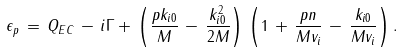Convert formula to latex. <formula><loc_0><loc_0><loc_500><loc_500>\epsilon _ { p } \, = \, Q _ { E C } \, - \, i \Gamma + \, \left ( \frac { p k _ { i 0 } } { M } \, - \, \frac { k ^ { 2 } _ { i 0 } } { 2 M } \right ) \, \left ( 1 \, + \, \frac { p n } { M v _ { i } } \, - \, \frac { k _ { i 0 } } { M v _ { i } } \right ) .</formula> 